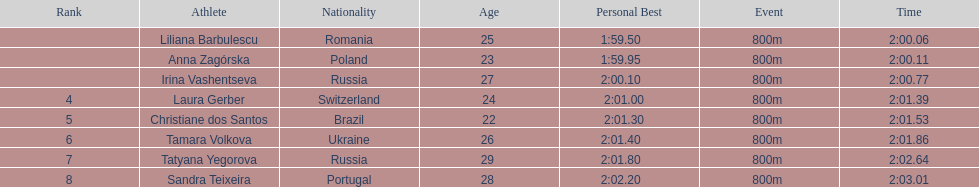In regards to anna zagorska, what was her finishing time? 2:00.11. 